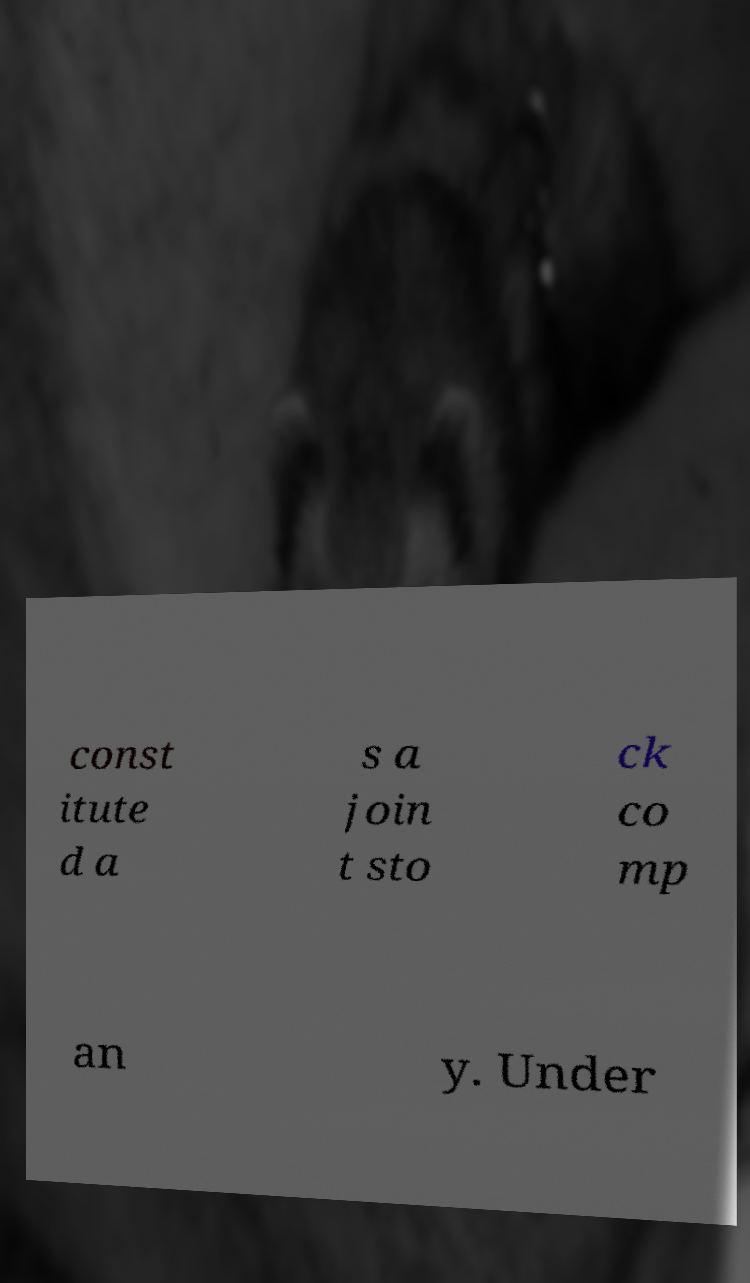I need the written content from this picture converted into text. Can you do that? const itute d a s a join t sto ck co mp an y. Under 